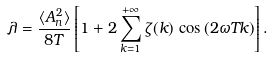<formula> <loc_0><loc_0><loc_500><loc_500>\lambda = \frac { \langle A _ { n } ^ { 2 } \rangle } { 8 T } \left [ 1 + 2 \sum _ { k = 1 } ^ { + \infty } \zeta ( k ) \, \cos \left ( 2 \omega T k \right ) \right ] .</formula> 